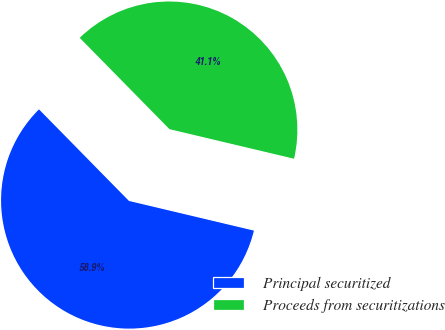<chart> <loc_0><loc_0><loc_500><loc_500><pie_chart><fcel>Principal securitized<fcel>Proceeds from securitizations<nl><fcel>58.93%<fcel>41.07%<nl></chart> 